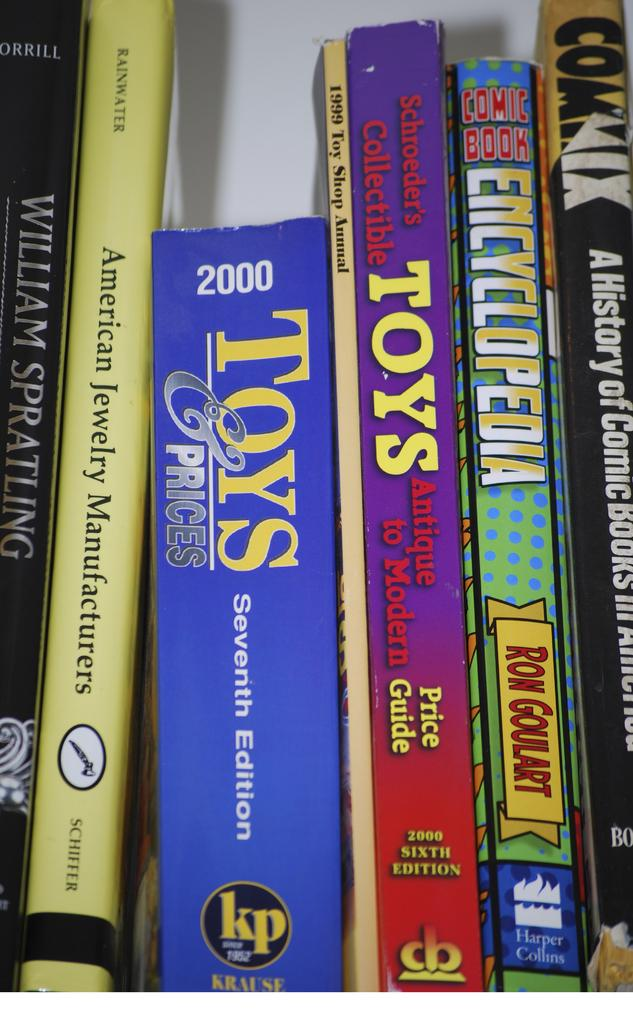<image>
Relay a brief, clear account of the picture shown. A shelf full of books contains titles such as Comic Book Encyclopedia, American Jewelry Manufacturers, and Toys & Prices. 